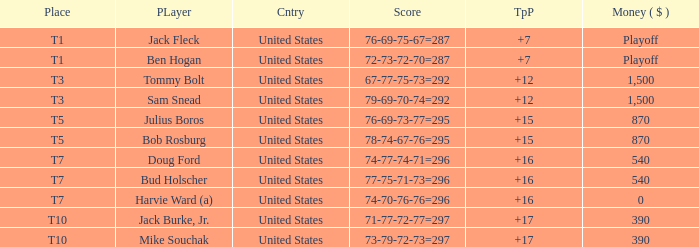What is the total of all to par with player Bob Rosburg? 15.0. 